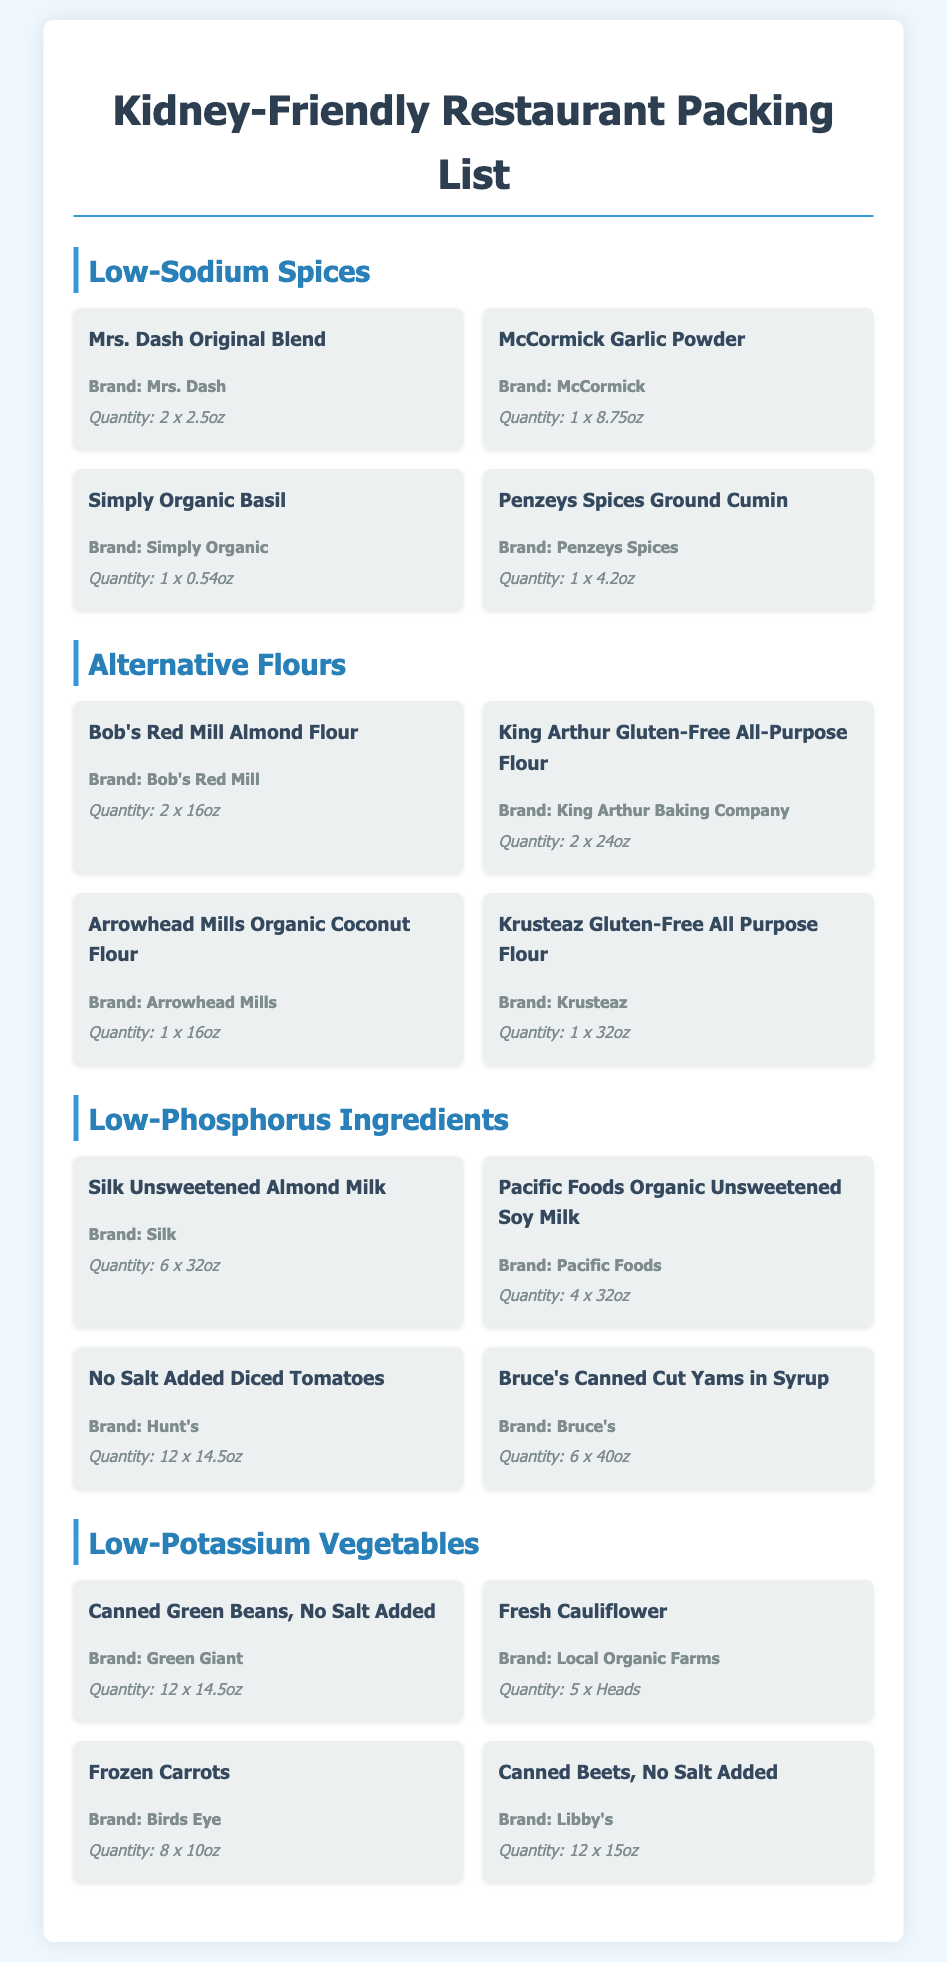what is the brand of the garlic powder? The brand of the garlic powder listed is McCormick.
Answer: McCormick how many ounces does the Mrs. Dash Original Blend contain? The Mrs. Dash Original Blend comes in containers of 2.5 ounces each and there are 2 containers.
Answer: 2.5oz how many cans of No Salt Added Diced Tomatoes are listed? The list states there are 12 cans of No Salt Added Diced Tomatoes.
Answer: 12 which alternative flour has the largest quantity? The Krusteaz Gluten-Free All Purpose Flour comes in a single 32oz container, which is the largest individual quantity listed among alternative flours.
Answer: 32oz which low-sodium spice is listed with a quantity of 1 x 8.75oz? The low-sodium spice listed with the quantity of 1 x 8.75oz is McCormick Garlic Powder.
Answer: McCormick Garlic Powder how many different brands are mentioned in the low-phosphorus ingredients section? The low-phosphorus ingredients section mentions four different brands: Silk, Pacific Foods, Hunt's, and Bruce's.
Answer: 4 what is the total quantity of canned green beans, no salt added? There are 12 cans of Canned Green Beans, No Salt Added listed in the document.
Answer: 12 which ingredient is categorized under low-potassium vegetables? Canned Beets, No Salt Added is categorized under low-potassium vegetables.
Answer: Canned Beets, No Salt Added how many different types of alternative flours are listed? There are four different types of alternative flours mentioned in the document.
Answer: 4 